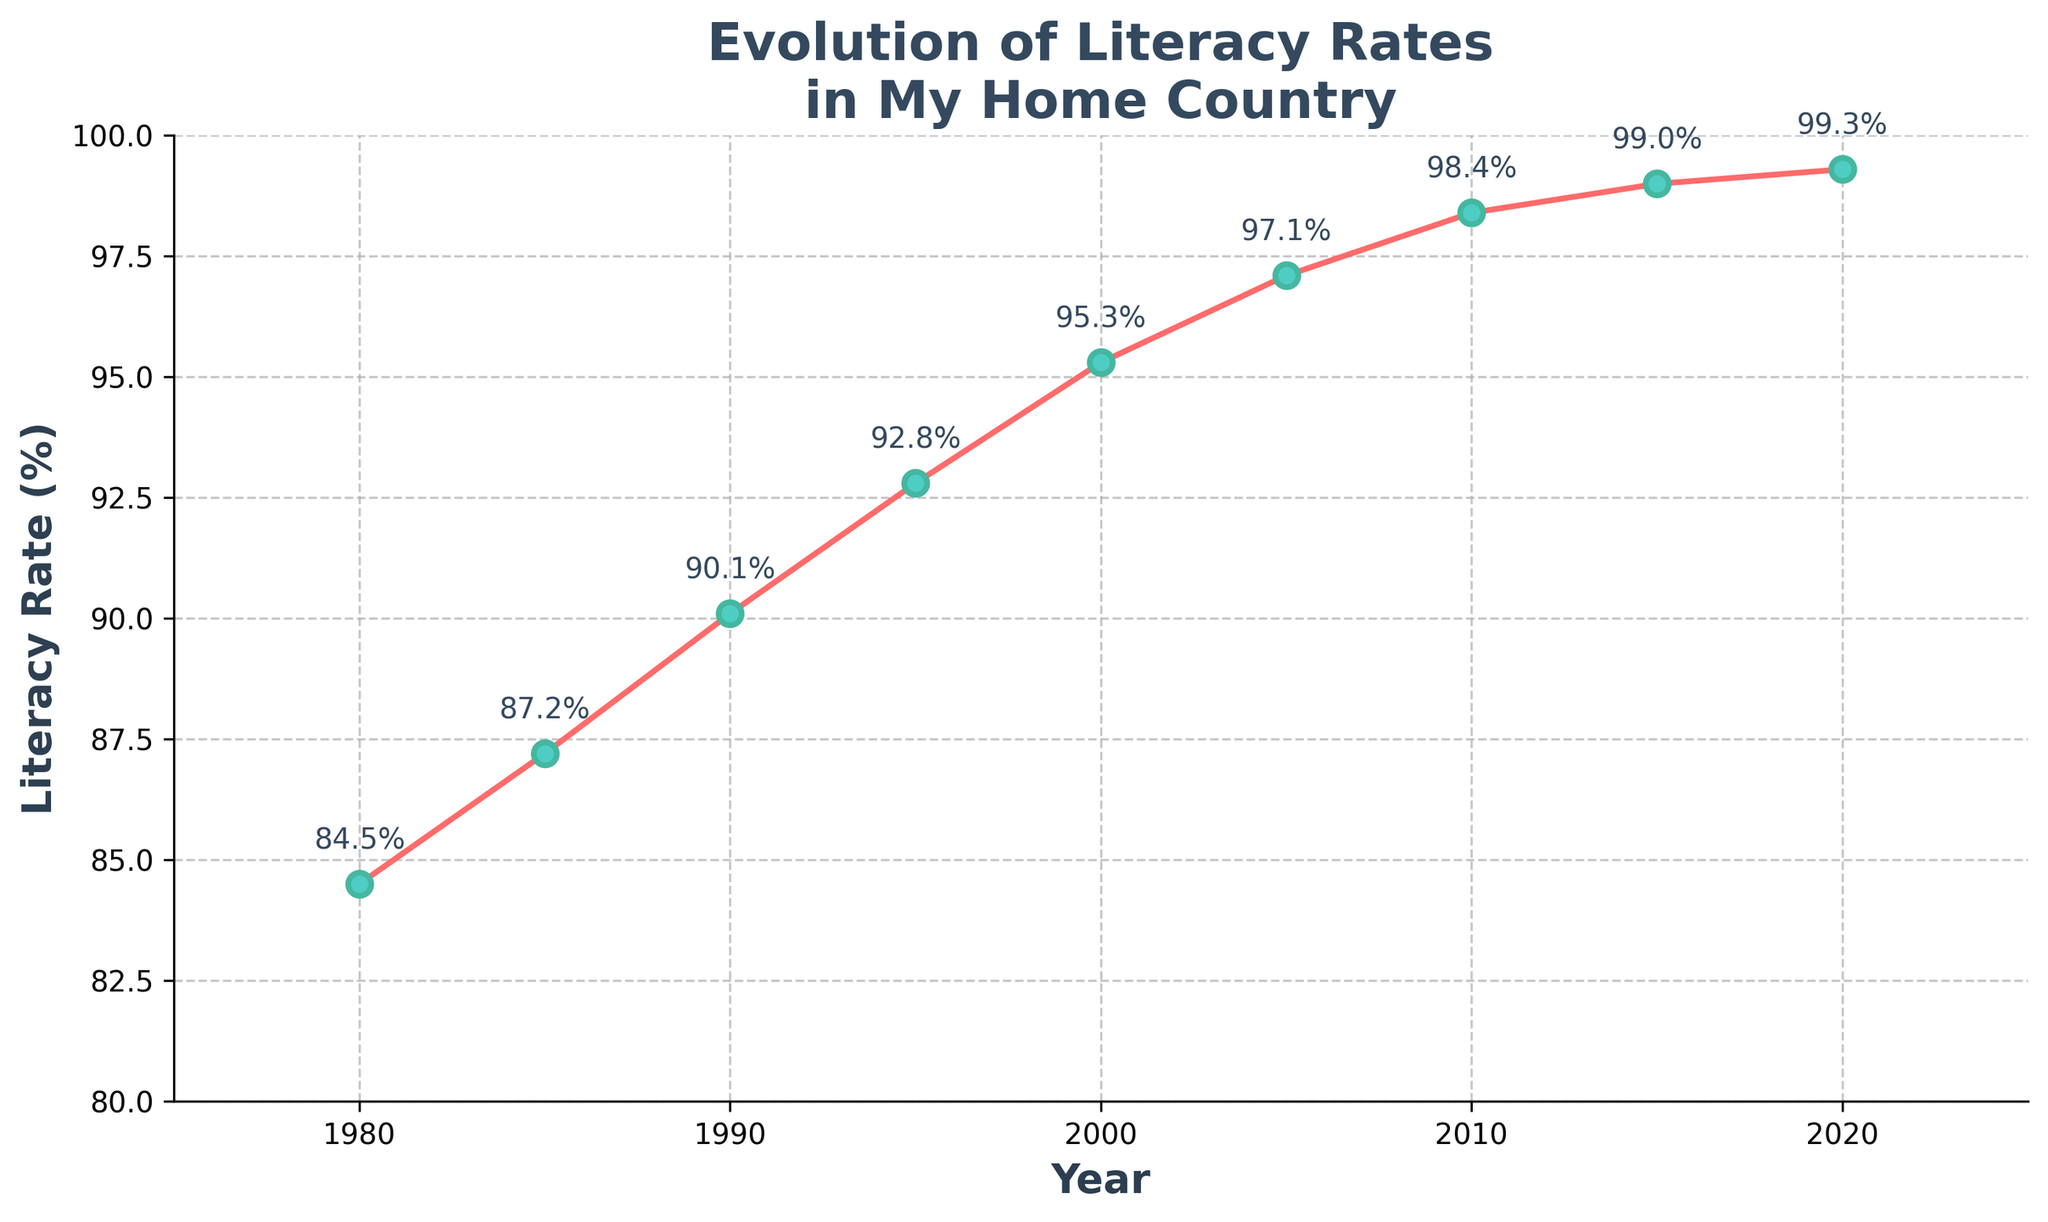What was the literacy rate in 1980? The plot has annotations indicating the literacy rate for each year. For 1980, the annotation shows 84.5%.
Answer: 84.5% How much did the literacy rate increase from 1980 to 2020? To find the increase, subtract the literacy rate in 1980 from the literacy rate in 2020. The literacy rate in 1980 was 84.5% and in 2020 it was 99.3%. The increase is 99.3% - 84.5% = 14.8%.
Answer: 14.8% Between which consecutive years did the literacy rate increase the most? Inspect the annotated data points to find the largest difference between consecutive years. The largest increase occurs between 1990 (90.1%) and 1995 (92.8%). The increase is 92.8% - 90.1% = 2.7%.
Answer: 1990 to 1995 How does the literacy rate trend visually change after 2005? Visually, after 2005, the curve shows a diminishing slope, indicating that the rate of increase in literacy is slowing down. Before 2005, the increases are more pronounced.
Answer: Slows down Approximately what is the average literacy rate from the data provided? First, add all the literacy rates together and then divide by the number of data points. The sum of the rates is 84.5 + 87.2 + 90.1 + 92.8 + 95.3 + 97.1 + 98.4 + 99.0 + 99.3 = 844.7. There are 9 data points, so the average is 844.7 / 9 ≈ 93.9%.
Answer: 93.9% In which year did the literacy rate first exceed 90%? Locate the first annotated data point where the literacy rate exceeds 90%. This occurs in 1990 with a literacy rate of 90.1%.
Answer: 1990 Is there any year where the literacy rate decreased compared to the previous year? Review the annotated data points. All years show an increase or remain unchanged in literacy rates compared to the previous year. Therefore, there are no decreases.
Answer: No What is the literacy rate's growth from 1980 to 2000? To determine the growth from 1980 to 2000, subtract the literacy rate in 1980 from that in 2000. The literacy rate in 1980 was 84.5%, and in 2000 it was 95.3%. Hence, the growth is 95.3% - 84.5% = 10.8%.
Answer: 10.8% Compare the literacy rate increases between 1985-1990 and 2000-2005. Which period had a larger increase? Calculate the increase for each period: 1985-1990 rate increase is 90.1% - 87.2% = 2.9%, and 2000-2005 rate increase is 97.1% - 95.3% = 1.8%. Therefore, 1985-1990 had a larger increase.
Answer: 1985-1990 